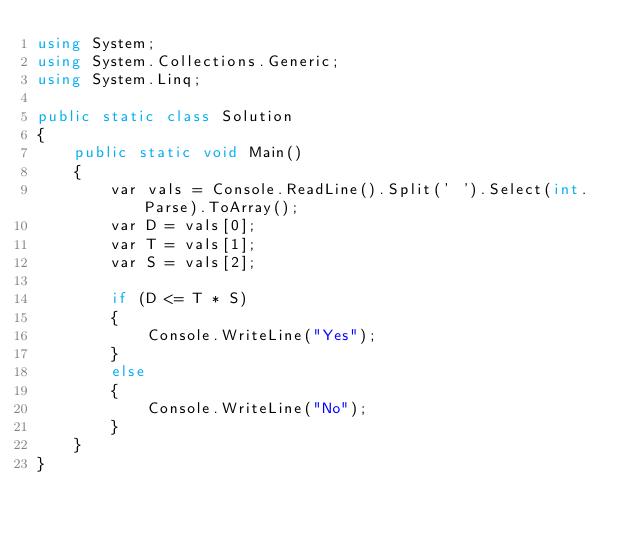<code> <loc_0><loc_0><loc_500><loc_500><_C#_>using System;
using System.Collections.Generic;
using System.Linq;

public static class Solution
{
    public static void Main()
    {
        var vals = Console.ReadLine().Split(' ').Select(int.Parse).ToArray();
        var D = vals[0];
        var T = vals[1];
        var S = vals[2];

        if (D <= T * S)
        {
            Console.WriteLine("Yes");
        }
        else
        {
            Console.WriteLine("No");
        }
    }
}</code> 